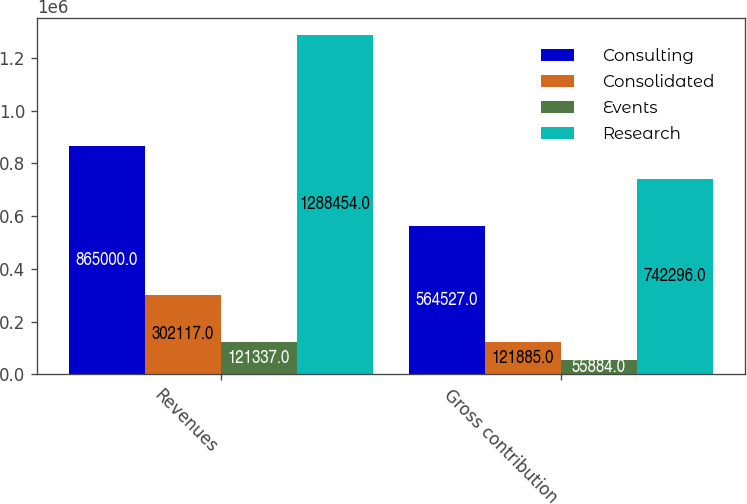Convert chart. <chart><loc_0><loc_0><loc_500><loc_500><stacked_bar_chart><ecel><fcel>Revenues<fcel>Gross contribution<nl><fcel>Consulting<fcel>865000<fcel>564527<nl><fcel>Consolidated<fcel>302117<fcel>121885<nl><fcel>Events<fcel>121337<fcel>55884<nl><fcel>Research<fcel>1.28845e+06<fcel>742296<nl></chart> 